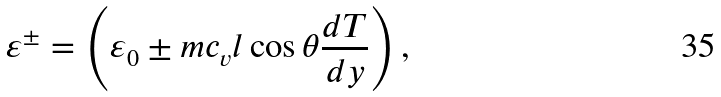<formula> <loc_0><loc_0><loc_500><loc_500>\varepsilon ^ { \pm } = \left ( \varepsilon _ { 0 } \pm m c _ { v } l \cos \theta { \frac { d T } { d y } } \right ) ,</formula> 